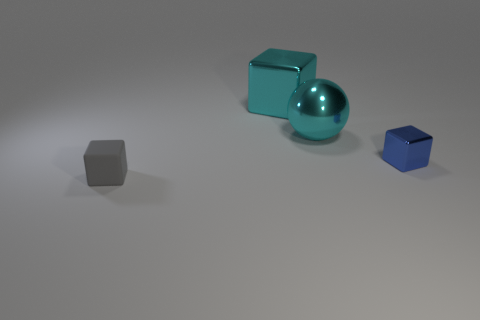How many other things are the same color as the ball?
Give a very brief answer. 1. Are there any big blocks that have the same color as the ball?
Your response must be concise. Yes. There is a small cube behind the tiny thing to the left of the small thing right of the gray thing; what is it made of?
Make the answer very short. Metal. Is there a cube that has the same material as the cyan sphere?
Provide a short and direct response. Yes. Is the small blue object made of the same material as the big cyan cube?
Your answer should be very brief. Yes. How many cylinders are green metallic objects or blue metal objects?
Your answer should be very brief. 0. There is a small block that is the same material as the large sphere; what is its color?
Provide a short and direct response. Blue. Is the number of tiny cubes less than the number of shiny things?
Your answer should be compact. Yes. There is a small thing to the right of the cyan ball; is its shape the same as the thing on the left side of the cyan shiny block?
Ensure brevity in your answer.  Yes. How many objects are gray things or purple metal objects?
Your response must be concise. 1. 